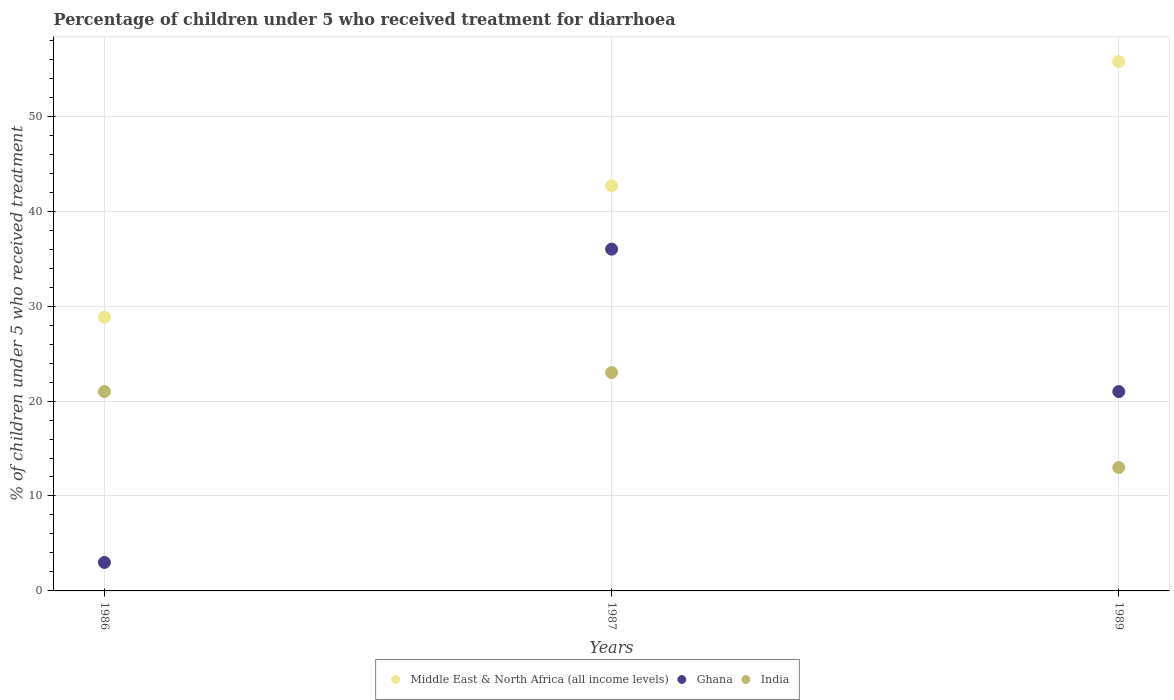Is the number of dotlines equal to the number of legend labels?
Give a very brief answer. Yes. What is the percentage of children who received treatment for diarrhoea  in Middle East & North Africa (all income levels) in 1987?
Make the answer very short. 42.68. What is the total percentage of children who received treatment for diarrhoea  in Middle East & North Africa (all income levels) in the graph?
Give a very brief answer. 127.27. What is the difference between the percentage of children who received treatment for diarrhoea  in Middle East & North Africa (all income levels) in 1986 and that in 1989?
Your answer should be compact. -26.92. In the year 1987, what is the difference between the percentage of children who received treatment for diarrhoea  in Middle East & North Africa (all income levels) and percentage of children who received treatment for diarrhoea  in India?
Offer a terse response. 19.68. In how many years, is the percentage of children who received treatment for diarrhoea  in Middle East & North Africa (all income levels) greater than 52 %?
Keep it short and to the point. 1. What is the ratio of the percentage of children who received treatment for diarrhoea  in India in 1986 to that in 1989?
Your answer should be compact. 1.62. What is the difference between the highest and the second highest percentage of children who received treatment for diarrhoea  in Middle East & North Africa (all income levels)?
Your answer should be very brief. 13.07. In how many years, is the percentage of children who received treatment for diarrhoea  in Middle East & North Africa (all income levels) greater than the average percentage of children who received treatment for diarrhoea  in Middle East & North Africa (all income levels) taken over all years?
Make the answer very short. 2. Is the sum of the percentage of children who received treatment for diarrhoea  in Ghana in 1986 and 1989 greater than the maximum percentage of children who received treatment for diarrhoea  in Middle East & North Africa (all income levels) across all years?
Offer a terse response. No. Is the percentage of children who received treatment for diarrhoea  in India strictly greater than the percentage of children who received treatment for diarrhoea  in Middle East & North Africa (all income levels) over the years?
Your answer should be compact. No. Are the values on the major ticks of Y-axis written in scientific E-notation?
Keep it short and to the point. No. Does the graph contain any zero values?
Your answer should be compact. No. Does the graph contain grids?
Make the answer very short. Yes. Where does the legend appear in the graph?
Your answer should be compact. Bottom center. How many legend labels are there?
Your answer should be compact. 3. What is the title of the graph?
Your answer should be compact. Percentage of children under 5 who received treatment for diarrhoea. Does "Aruba" appear as one of the legend labels in the graph?
Offer a terse response. No. What is the label or title of the X-axis?
Offer a very short reply. Years. What is the label or title of the Y-axis?
Offer a terse response. % of children under 5 who received treatment. What is the % of children under 5 who received treatment of Middle East & North Africa (all income levels) in 1986?
Offer a very short reply. 28.84. What is the % of children under 5 who received treatment of India in 1986?
Ensure brevity in your answer.  21. What is the % of children under 5 who received treatment of Middle East & North Africa (all income levels) in 1987?
Offer a terse response. 42.68. What is the % of children under 5 who received treatment of India in 1987?
Keep it short and to the point. 23. What is the % of children under 5 who received treatment of Middle East & North Africa (all income levels) in 1989?
Make the answer very short. 55.75. What is the % of children under 5 who received treatment of Ghana in 1989?
Give a very brief answer. 21. What is the % of children under 5 who received treatment of India in 1989?
Your response must be concise. 13. Across all years, what is the maximum % of children under 5 who received treatment in Middle East & North Africa (all income levels)?
Make the answer very short. 55.75. Across all years, what is the maximum % of children under 5 who received treatment of India?
Provide a succinct answer. 23. Across all years, what is the minimum % of children under 5 who received treatment in Middle East & North Africa (all income levels)?
Provide a succinct answer. 28.84. Across all years, what is the minimum % of children under 5 who received treatment in India?
Your answer should be compact. 13. What is the total % of children under 5 who received treatment of Middle East & North Africa (all income levels) in the graph?
Your response must be concise. 127.27. What is the total % of children under 5 who received treatment of Ghana in the graph?
Provide a short and direct response. 60. What is the difference between the % of children under 5 who received treatment in Middle East & North Africa (all income levels) in 1986 and that in 1987?
Give a very brief answer. -13.84. What is the difference between the % of children under 5 who received treatment in Ghana in 1986 and that in 1987?
Provide a succinct answer. -33. What is the difference between the % of children under 5 who received treatment in Middle East & North Africa (all income levels) in 1986 and that in 1989?
Ensure brevity in your answer.  -26.92. What is the difference between the % of children under 5 who received treatment of Middle East & North Africa (all income levels) in 1987 and that in 1989?
Offer a terse response. -13.07. What is the difference between the % of children under 5 who received treatment in Middle East & North Africa (all income levels) in 1986 and the % of children under 5 who received treatment in Ghana in 1987?
Your answer should be compact. -7.16. What is the difference between the % of children under 5 who received treatment of Middle East & North Africa (all income levels) in 1986 and the % of children under 5 who received treatment of India in 1987?
Your response must be concise. 5.84. What is the difference between the % of children under 5 who received treatment of Middle East & North Africa (all income levels) in 1986 and the % of children under 5 who received treatment of Ghana in 1989?
Ensure brevity in your answer.  7.84. What is the difference between the % of children under 5 who received treatment of Middle East & North Africa (all income levels) in 1986 and the % of children under 5 who received treatment of India in 1989?
Ensure brevity in your answer.  15.84. What is the difference between the % of children under 5 who received treatment in Ghana in 1986 and the % of children under 5 who received treatment in India in 1989?
Give a very brief answer. -10. What is the difference between the % of children under 5 who received treatment in Middle East & North Africa (all income levels) in 1987 and the % of children under 5 who received treatment in Ghana in 1989?
Offer a terse response. 21.68. What is the difference between the % of children under 5 who received treatment of Middle East & North Africa (all income levels) in 1987 and the % of children under 5 who received treatment of India in 1989?
Provide a short and direct response. 29.68. What is the difference between the % of children under 5 who received treatment in Ghana in 1987 and the % of children under 5 who received treatment in India in 1989?
Keep it short and to the point. 23. What is the average % of children under 5 who received treatment of Middle East & North Africa (all income levels) per year?
Provide a succinct answer. 42.42. What is the average % of children under 5 who received treatment of Ghana per year?
Provide a succinct answer. 20. What is the average % of children under 5 who received treatment in India per year?
Your response must be concise. 19. In the year 1986, what is the difference between the % of children under 5 who received treatment in Middle East & North Africa (all income levels) and % of children under 5 who received treatment in Ghana?
Ensure brevity in your answer.  25.84. In the year 1986, what is the difference between the % of children under 5 who received treatment in Middle East & North Africa (all income levels) and % of children under 5 who received treatment in India?
Give a very brief answer. 7.84. In the year 1987, what is the difference between the % of children under 5 who received treatment in Middle East & North Africa (all income levels) and % of children under 5 who received treatment in Ghana?
Provide a short and direct response. 6.68. In the year 1987, what is the difference between the % of children under 5 who received treatment of Middle East & North Africa (all income levels) and % of children under 5 who received treatment of India?
Your response must be concise. 19.68. In the year 1989, what is the difference between the % of children under 5 who received treatment in Middle East & North Africa (all income levels) and % of children under 5 who received treatment in Ghana?
Keep it short and to the point. 34.75. In the year 1989, what is the difference between the % of children under 5 who received treatment in Middle East & North Africa (all income levels) and % of children under 5 who received treatment in India?
Provide a succinct answer. 42.75. What is the ratio of the % of children under 5 who received treatment in Middle East & North Africa (all income levels) in 1986 to that in 1987?
Offer a terse response. 0.68. What is the ratio of the % of children under 5 who received treatment of Ghana in 1986 to that in 1987?
Offer a terse response. 0.08. What is the ratio of the % of children under 5 who received treatment of Middle East & North Africa (all income levels) in 1986 to that in 1989?
Offer a terse response. 0.52. What is the ratio of the % of children under 5 who received treatment of Ghana in 1986 to that in 1989?
Provide a succinct answer. 0.14. What is the ratio of the % of children under 5 who received treatment in India in 1986 to that in 1989?
Give a very brief answer. 1.62. What is the ratio of the % of children under 5 who received treatment in Middle East & North Africa (all income levels) in 1987 to that in 1989?
Make the answer very short. 0.77. What is the ratio of the % of children under 5 who received treatment of Ghana in 1987 to that in 1989?
Keep it short and to the point. 1.71. What is the ratio of the % of children under 5 who received treatment in India in 1987 to that in 1989?
Give a very brief answer. 1.77. What is the difference between the highest and the second highest % of children under 5 who received treatment of Middle East & North Africa (all income levels)?
Give a very brief answer. 13.07. What is the difference between the highest and the lowest % of children under 5 who received treatment in Middle East & North Africa (all income levels)?
Your answer should be very brief. 26.92. What is the difference between the highest and the lowest % of children under 5 who received treatment of India?
Your answer should be very brief. 10. 